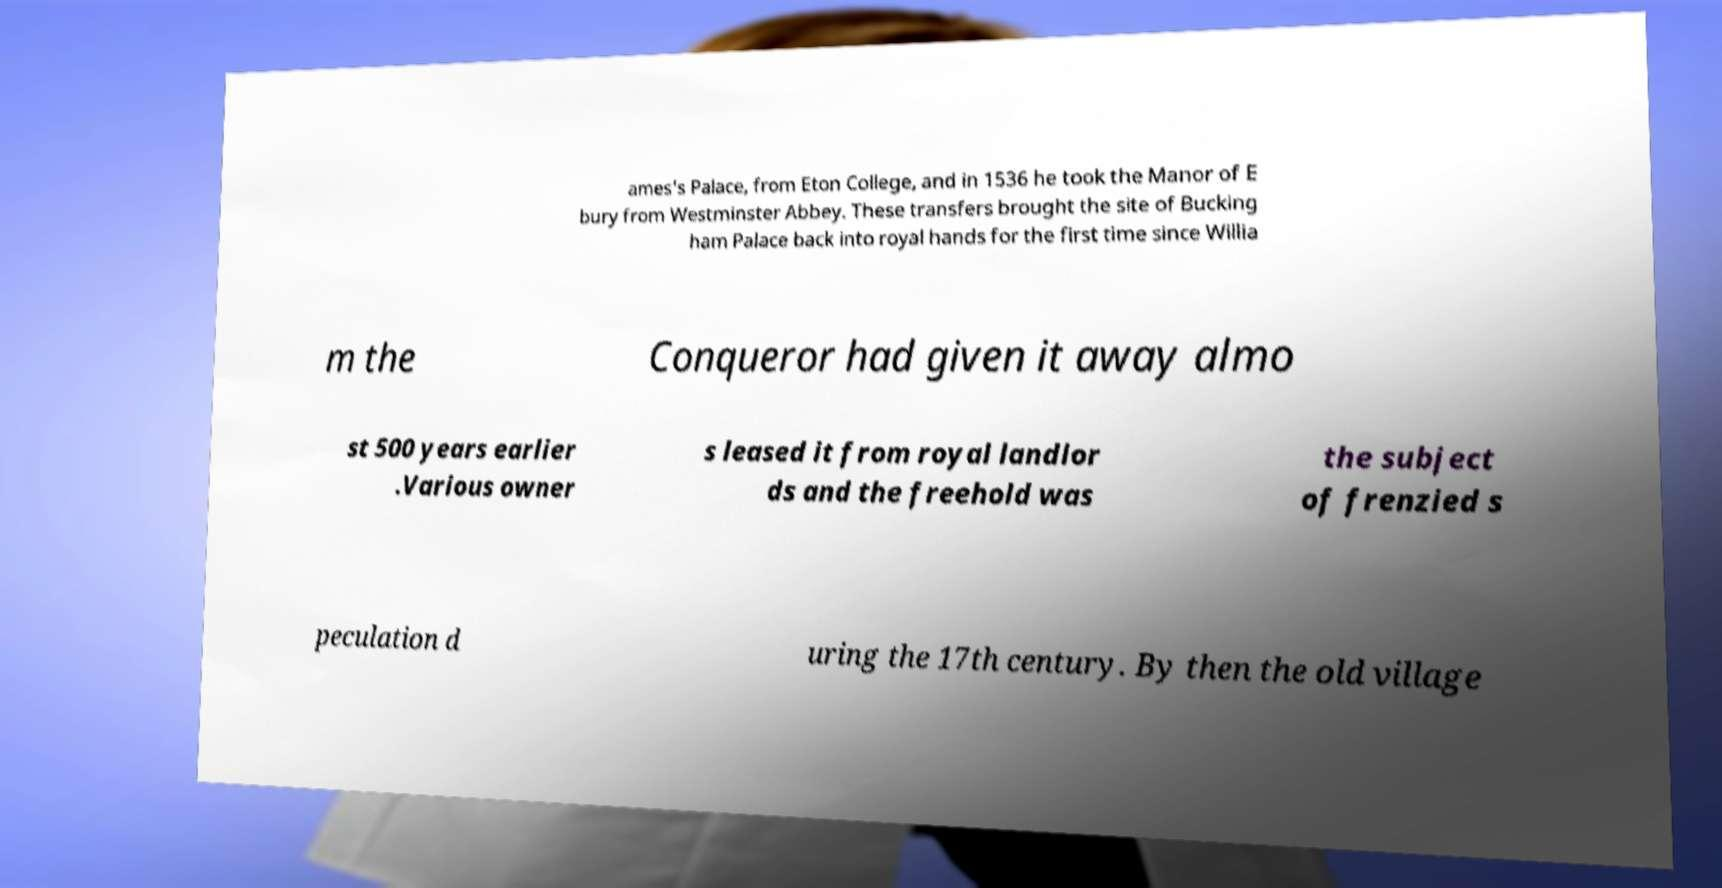Could you extract and type out the text from this image? ames's Palace, from Eton College, and in 1536 he took the Manor of E bury from Westminster Abbey. These transfers brought the site of Bucking ham Palace back into royal hands for the first time since Willia m the Conqueror had given it away almo st 500 years earlier .Various owner s leased it from royal landlor ds and the freehold was the subject of frenzied s peculation d uring the 17th century. By then the old village 